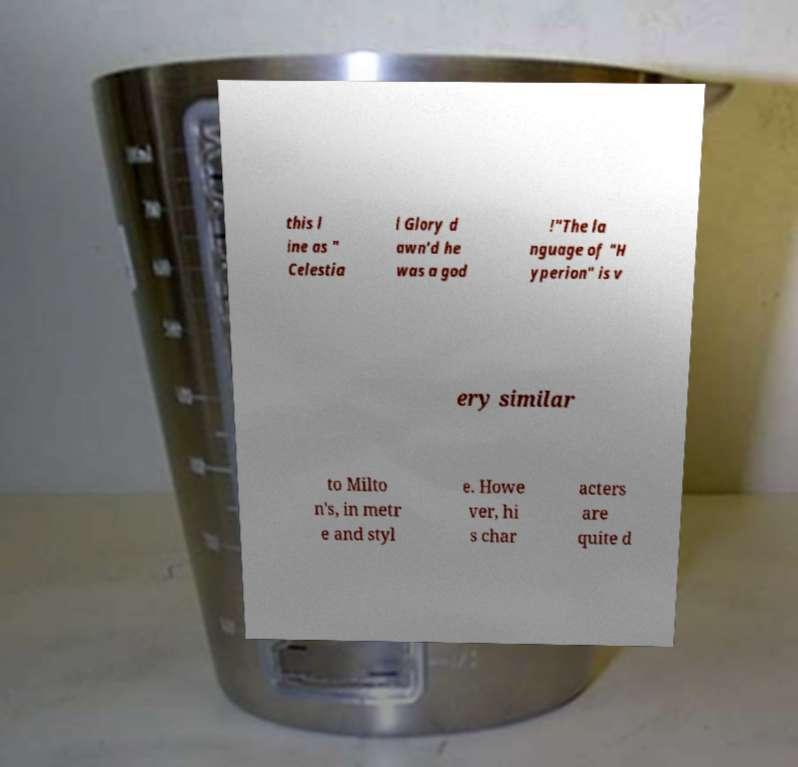Could you extract and type out the text from this image? this l ine as " Celestia l Glory d awn'd he was a god !"The la nguage of "H yperion" is v ery similar to Milto n's, in metr e and styl e. Howe ver, hi s char acters are quite d 